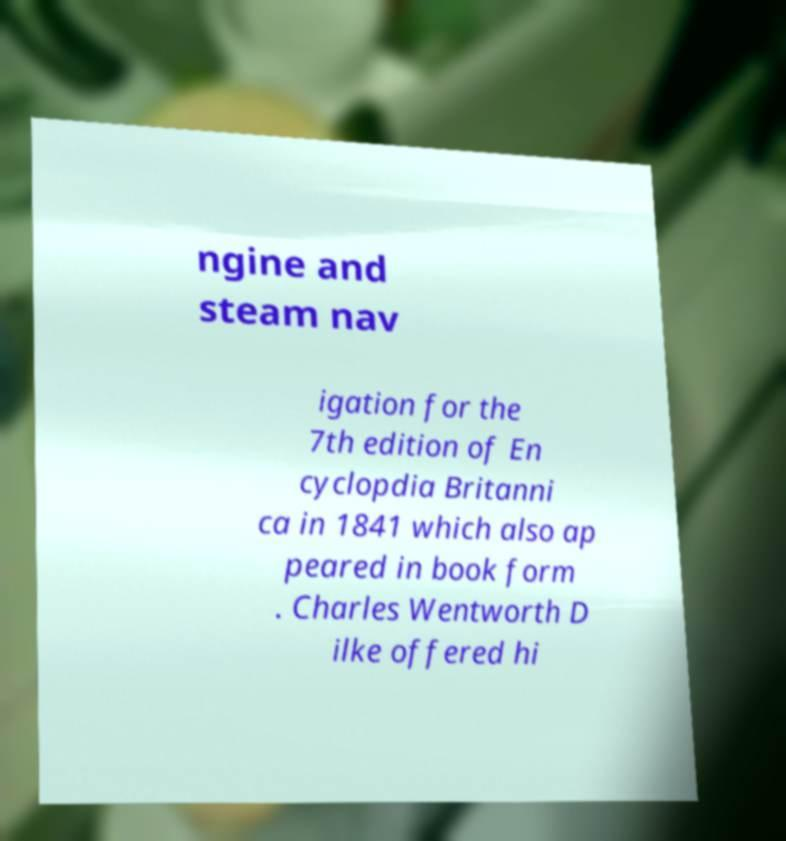Can you read and provide the text displayed in the image?This photo seems to have some interesting text. Can you extract and type it out for me? ngine and steam nav igation for the 7th edition of En cyclopdia Britanni ca in 1841 which also ap peared in book form . Charles Wentworth D ilke offered hi 